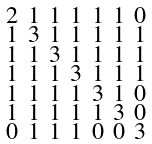Convert formula to latex. <formula><loc_0><loc_0><loc_500><loc_500>\begin{smallmatrix} 2 & 1 & 1 & 1 & 1 & 1 & 0 \\ 1 & 3 & 1 & 1 & 1 & 1 & 1 \\ 1 & 1 & 3 & 1 & 1 & 1 & 1 \\ 1 & 1 & 1 & 3 & 1 & 1 & 1 \\ 1 & 1 & 1 & 1 & 3 & 1 & 0 \\ 1 & 1 & 1 & 1 & 1 & 3 & 0 \\ 0 & 1 & 1 & 1 & 0 & 0 & 3 \end{smallmatrix}</formula> 